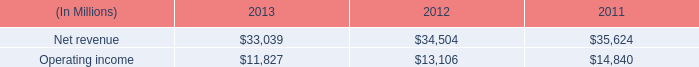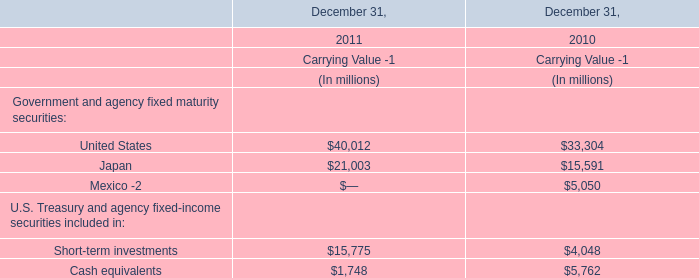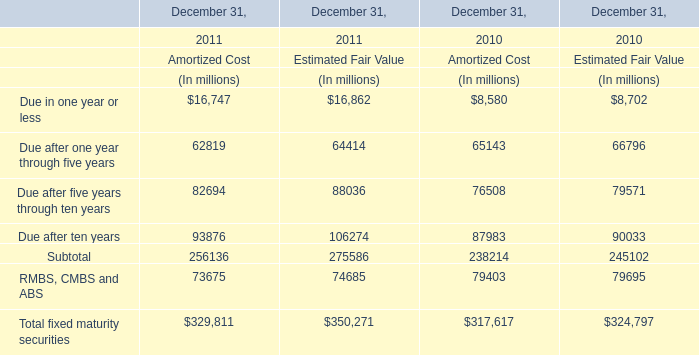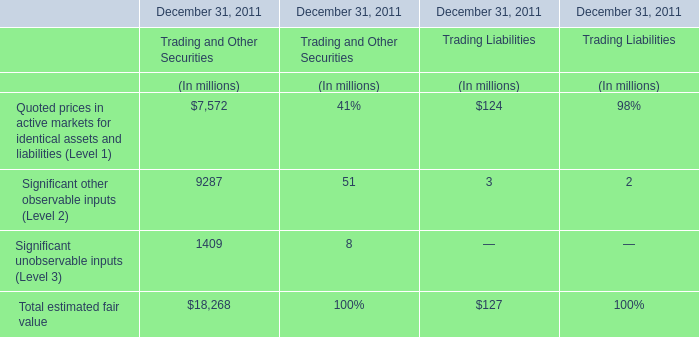what is the highest total amount of United States ? 
Answer: 40012. 